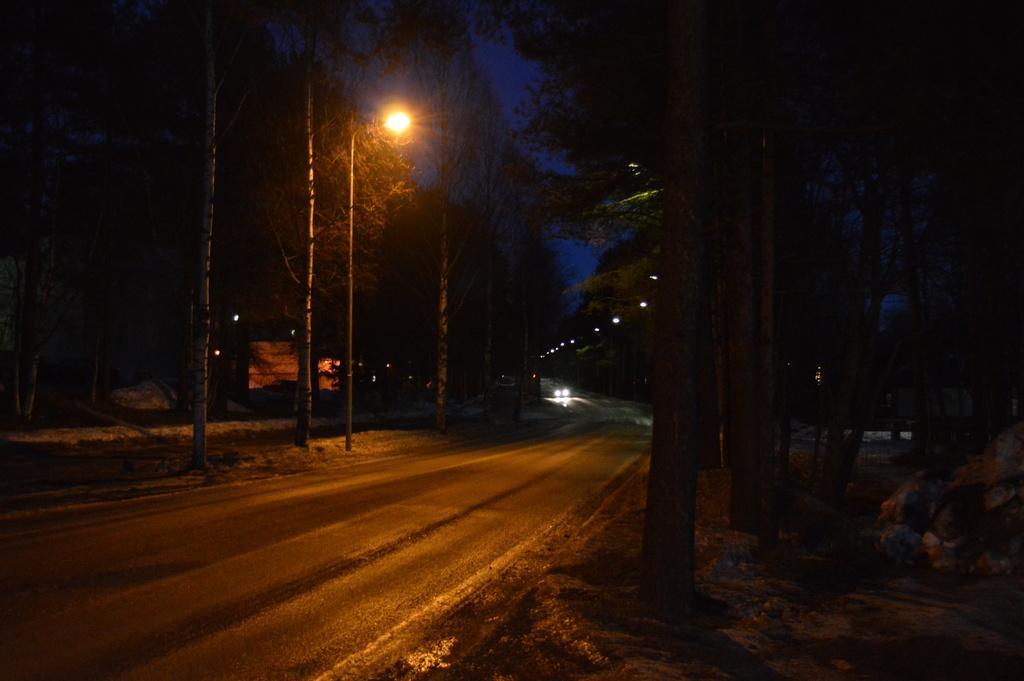In one or two sentences, can you explain what this image depicts? This is an image clicked in the dark. Here I can see a road. In the background there are some vehicles. On both sides of the road I can see some street lights and trees. 